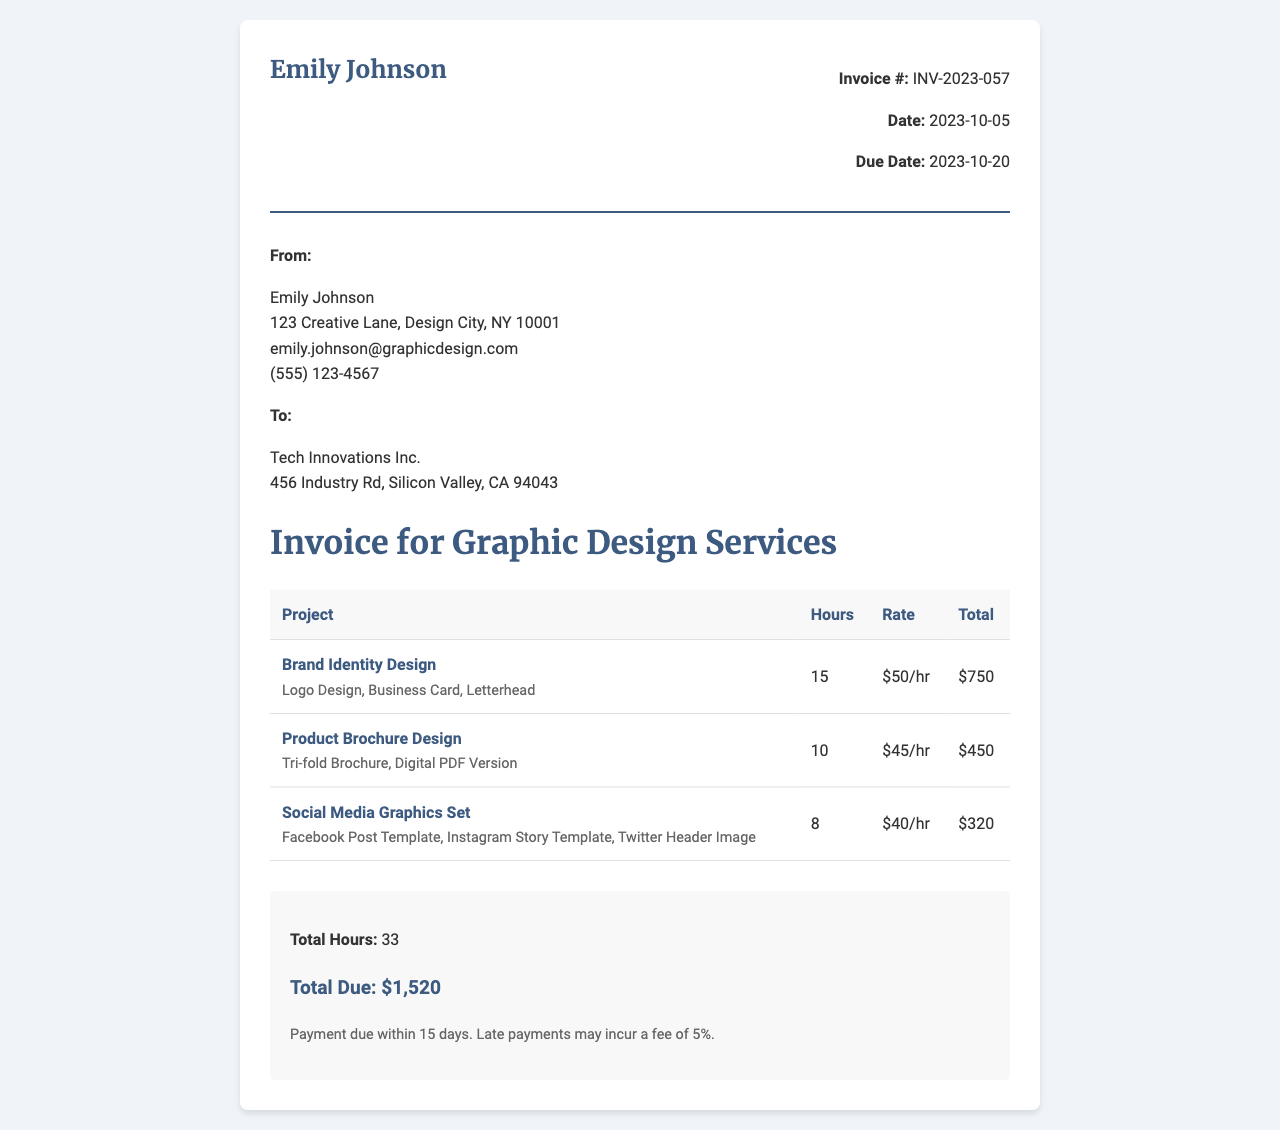What is the invoice number? The invoice number is indicated at the top right of the document under "Invoice #".
Answer: INV-2023-057 Who is the service provider? The service provider's name is at the top of the invoice under "From:".
Answer: Emily Johnson What is the total due amount? The total due amount is provided in the summary section at the bottom of the invoice.
Answer: $1,520 How many hours were worked in total? The total hours worked is summarized at the bottom of the invoice, combining all projects.
Answer: 33 What is the due date for payment? The due date is listed under the invoice details section.
Answer: 2023-10-20 What is the hourly rate for Brand Identity Design? The rate is provided in the table next to the project name.
Answer: $50/hr Which project had the least hours worked? The project with the least hours is determined by comparing the hours listed for each project.
Answer: Social Media Graphics Set What are the deliverables for the Product Brochure Design? The deliverables are listed under the related project in the invoice table.
Answer: Tri-fold Brochure, Digital PDF Version What are the payment terms stated in the invoice? The payment terms are provided in the summary section at the bottom of the invoice.
Answer: Payment due within 15 days. Late payments may incur a fee of 5% 